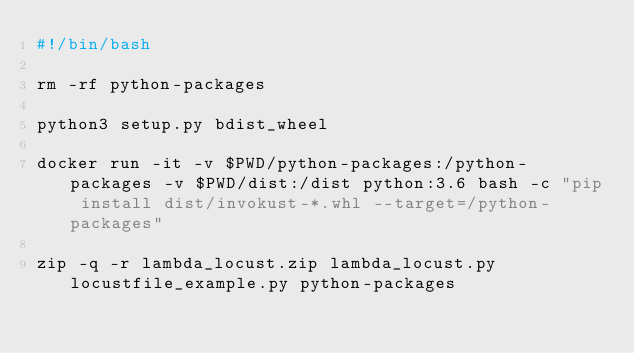Convert code to text. <code><loc_0><loc_0><loc_500><loc_500><_Bash_>#!/bin/bash

rm -rf python-packages

python3 setup.py bdist_wheel

docker run -it -v $PWD/python-packages:/python-packages -v $PWD/dist:/dist python:3.6 bash -c "pip install dist/invokust-*.whl --target=/python-packages"

zip -q -r lambda_locust.zip lambda_locust.py locustfile_example.py python-packages</code> 